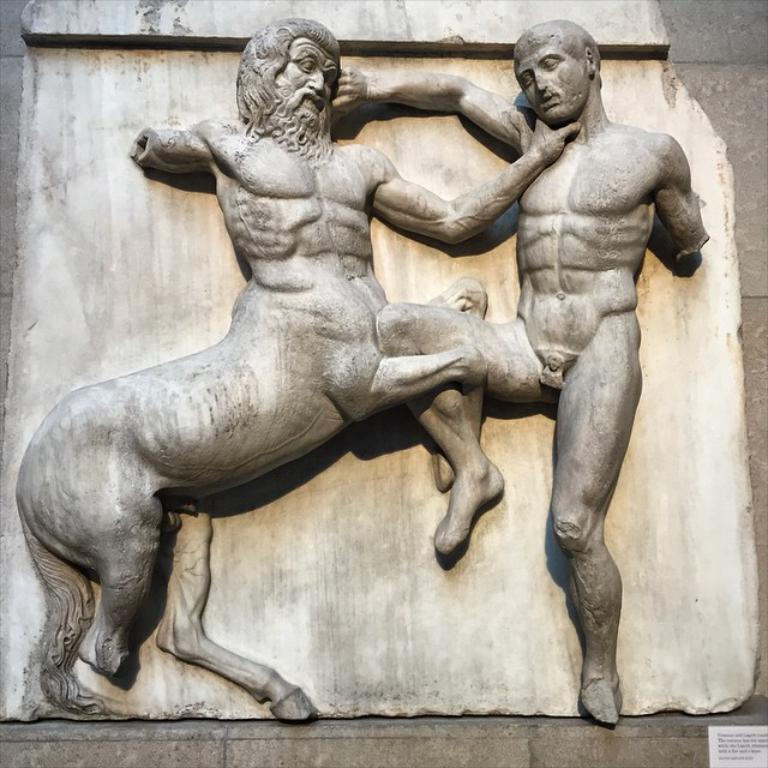In one or two sentences, can you explain what this image depicts? In this image we can see two sculptures on the wall. 